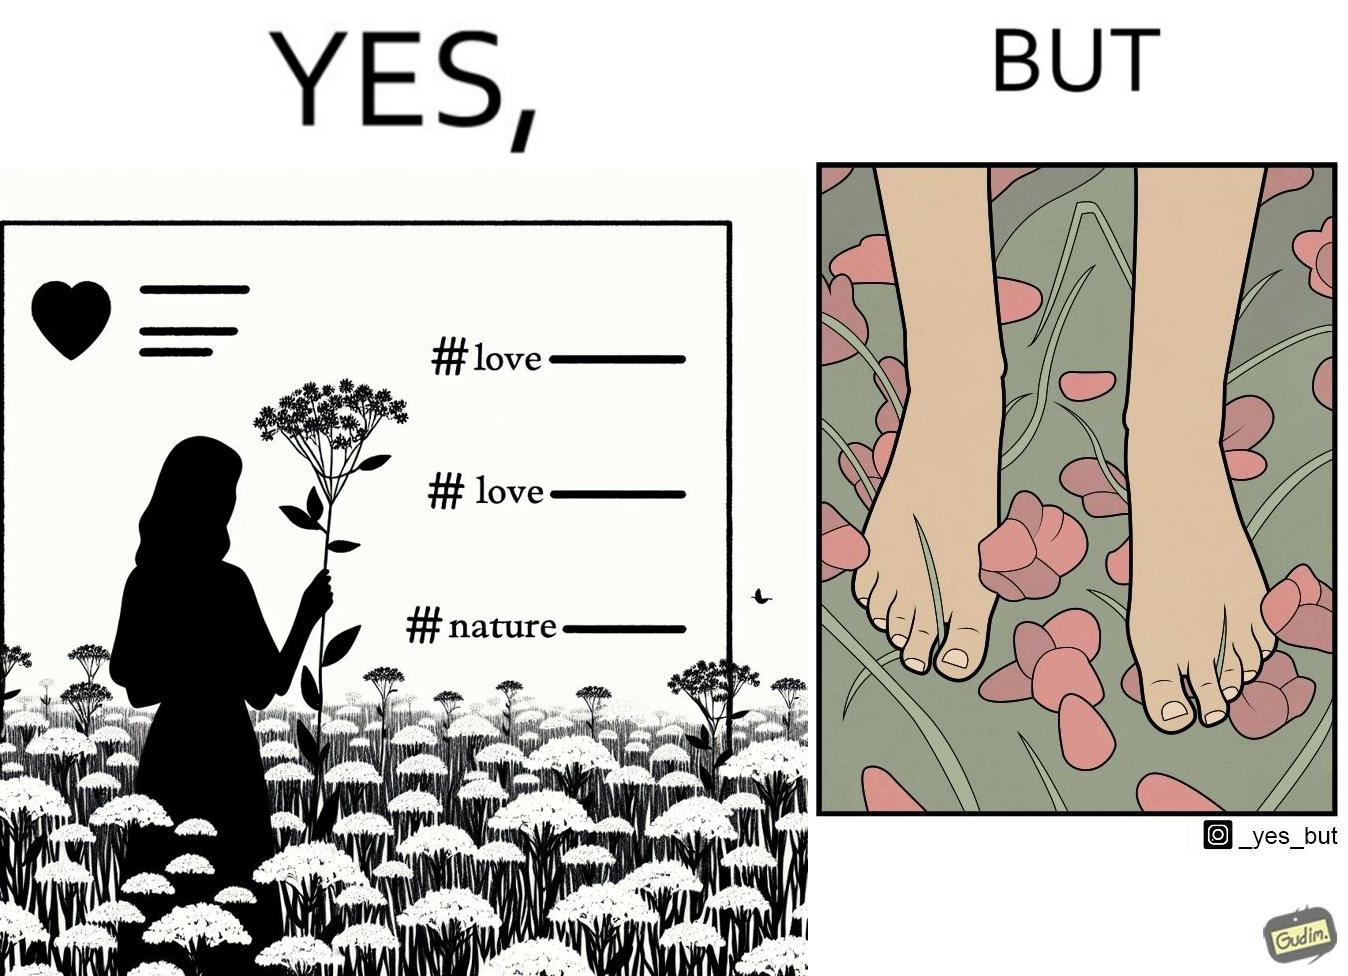What does this image depict? The image is ironical, as the social ,edia post shows the appreciation of nature, while an image of the feet on the ground stepping on the flower petals shows an unintentional disrespect of nature. 